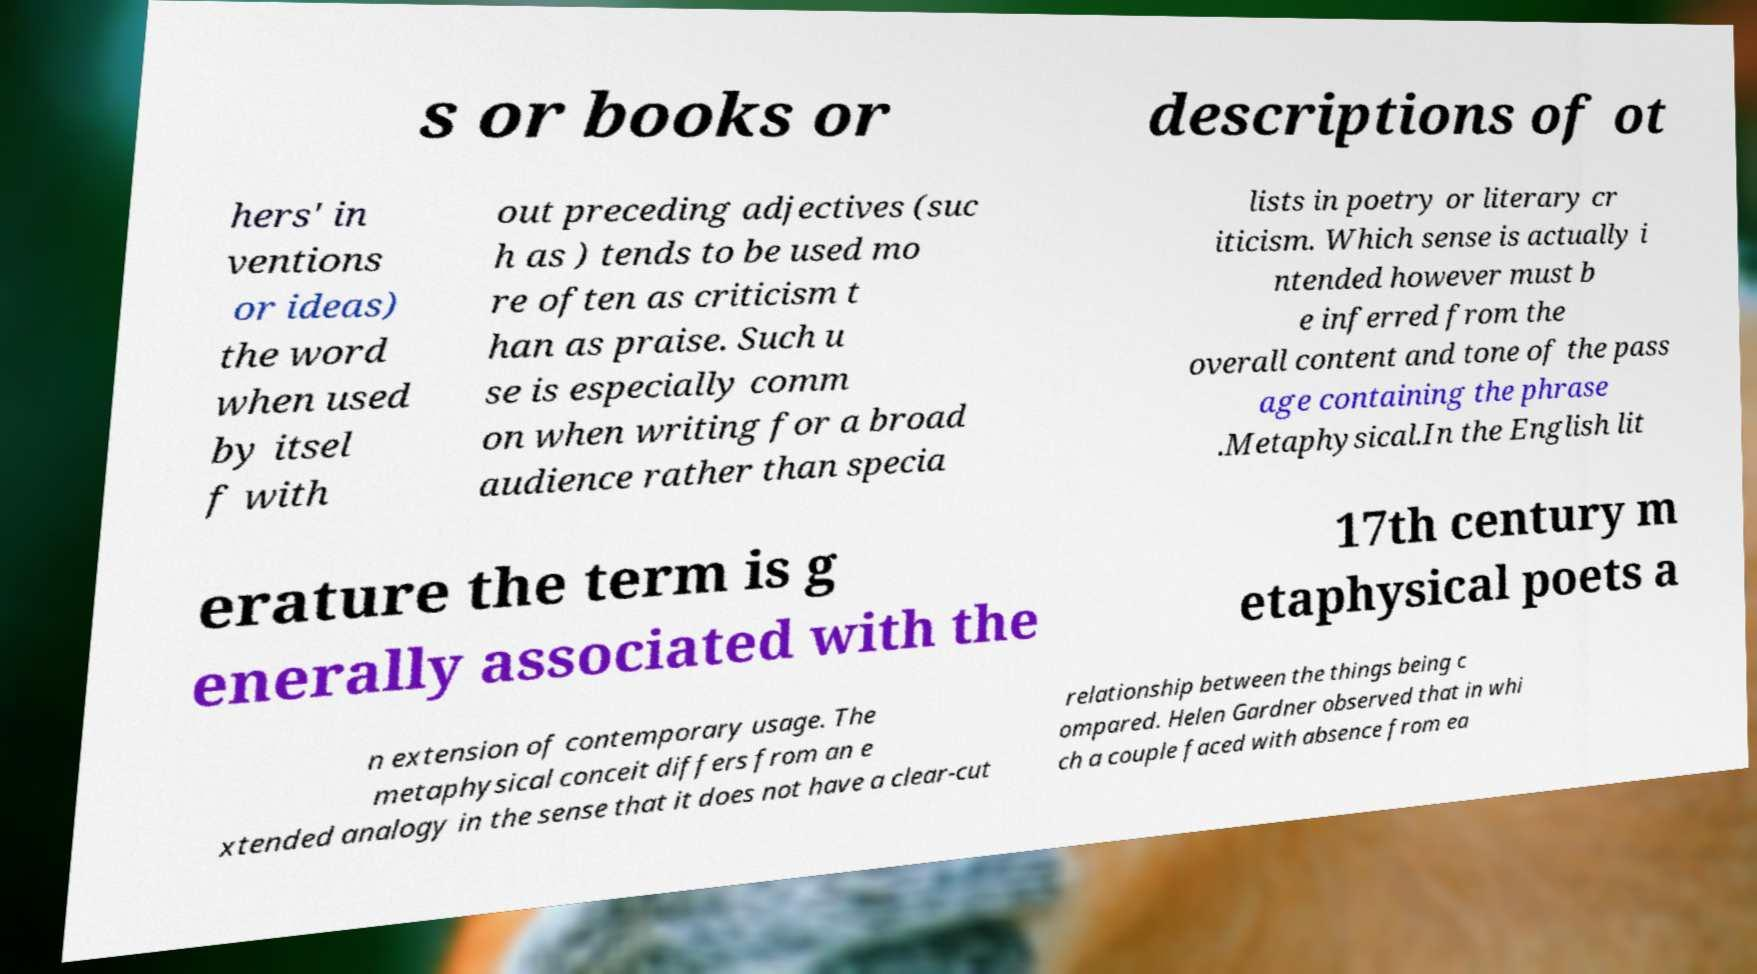Could you assist in decoding the text presented in this image and type it out clearly? s or books or descriptions of ot hers' in ventions or ideas) the word when used by itsel f with out preceding adjectives (suc h as ) tends to be used mo re often as criticism t han as praise. Such u se is especially comm on when writing for a broad audience rather than specia lists in poetry or literary cr iticism. Which sense is actually i ntended however must b e inferred from the overall content and tone of the pass age containing the phrase .Metaphysical.In the English lit erature the term is g enerally associated with the 17th century m etaphysical poets a n extension of contemporary usage. The metaphysical conceit differs from an e xtended analogy in the sense that it does not have a clear-cut relationship between the things being c ompared. Helen Gardner observed that in whi ch a couple faced with absence from ea 